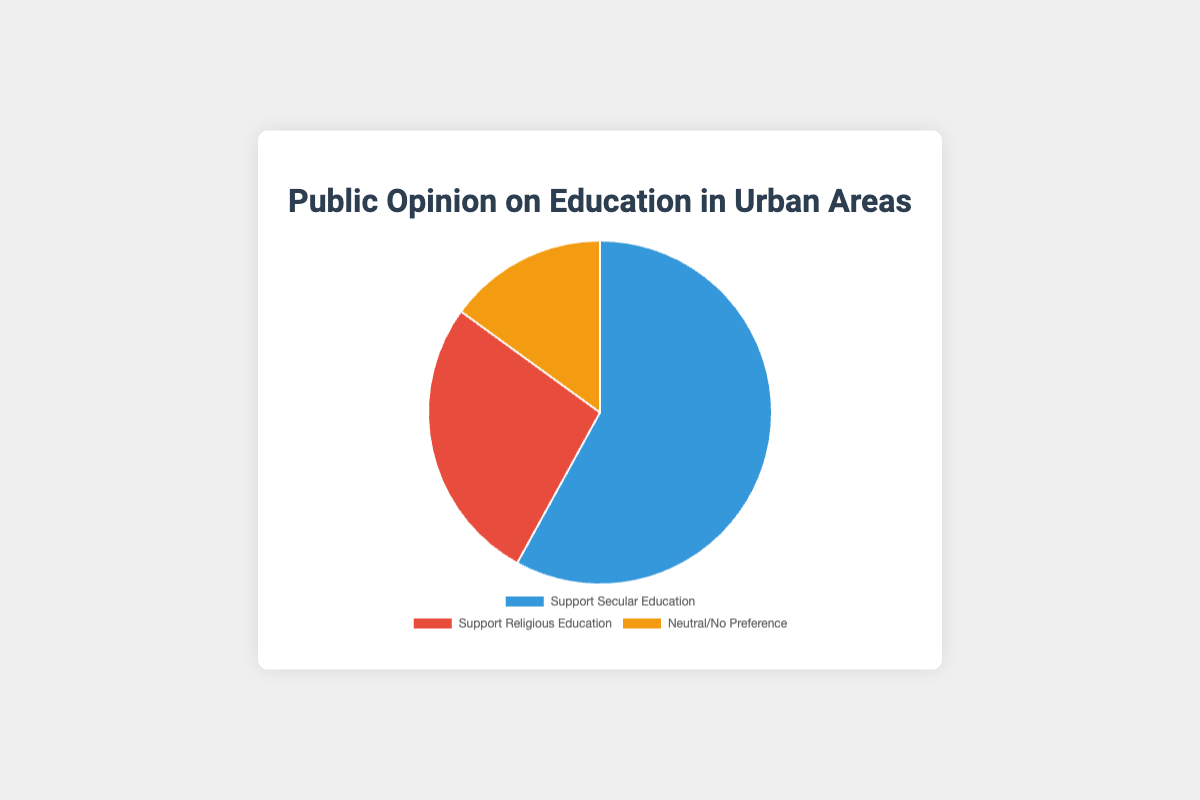Which category received the highest support? The category 'Support Secular Education' has the highest percentage in the pie chart at 58%.
Answer: Support Secular Education Which category has the lowest support? The category 'Neutral/No Preference' has the lowest percentage in the pie chart at 15%.
Answer: Neutral/No Preference What is the percentage difference between supporters of secular education and religious education? Subtract the percentage of 'Support Religious Education' (27%) from 'Support Secular Education' (58%): 58 - 27 = 31%
Answer: 31% What percentage of people either support secular education or have no preference? Add the percentages of 'Support Secular Education' (58%) and 'Neutral/No Preference' (15%): 58 + 15 = 73%
Answer: 73% How does the support for religious education compare to the support for secular education? The support for secular education (58%) is more than double the support for religious education (27%).
Answer: More than double Are there more people who are neutral/no preference compared to those who support religious education? Compare the percentages: 'Neutral/No Preference' is 15% and 'Support Religious Education' is 27%. 15% is less than 27%.
Answer: No Which section of the pie chart is shown in blue? The legend shows 'Support Secular Education' is represented in blue.
Answer: Support Secular Education How many percentage points greater is the support for secular education compared to those who are neutral/no preference? Subtract the percentage of 'Neutral/No Preference' (15%) from 'Support Secular Education' (58%): 58 - 15 = 43%
Answer: 43% If you combine the percentages of supporters of religious education and those who are neutral/no preference, how does it compare to supporters of secular education? Add the percentages of 'Support Religious Education' (27%) and 'Neutral/No Preference' (15%): 27 + 15 = 42%. Compare it to 'Support Secular Education' (58%): 58% is greater than 42%.
Answer: Less What is the total percentage represented by the entire pie chart? The pie chart represents 100% as it accounts for all responses in the survey.
Answer: 100% 